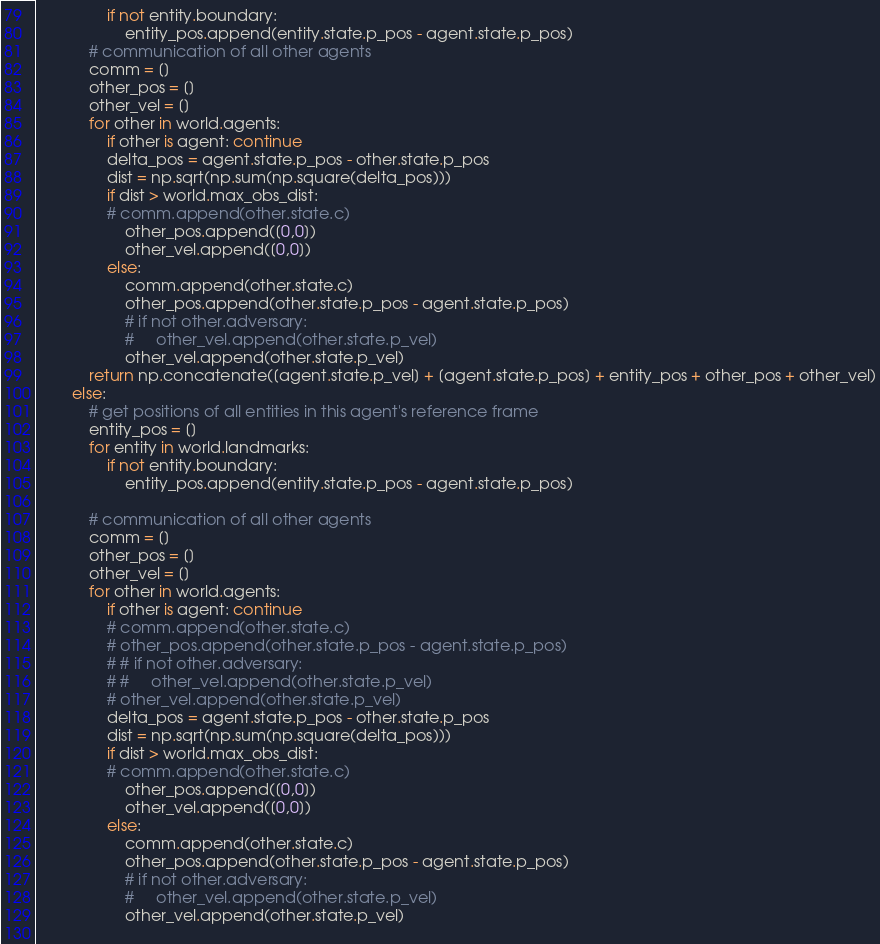Convert code to text. <code><loc_0><loc_0><loc_500><loc_500><_Python_>                if not entity.boundary:
                    entity_pos.append(entity.state.p_pos - agent.state.p_pos)
            # communication of all other agents
            comm = []
            other_pos = []
            other_vel = []
            for other in world.agents:
                if other is agent: continue
                delta_pos = agent.state.p_pos - other.state.p_pos
                dist = np.sqrt(np.sum(np.square(delta_pos)))
                if dist > world.max_obs_dist:
                # comm.append(other.state.c)
                    other_pos.append([0,0])
                    other_vel.append([0,0])
                else:
                    comm.append(other.state.c)
                    other_pos.append(other.state.p_pos - agent.state.p_pos)
                    # if not other.adversary:
                    #     other_vel.append(other.state.p_vel)
                    other_vel.append(other.state.p_vel)
            return np.concatenate([agent.state.p_vel] + [agent.state.p_pos] + entity_pos + other_pos + other_vel)
        else:
            # get positions of all entities in this agent's reference frame
            entity_pos = []
            for entity in world.landmarks:
                if not entity.boundary:
                    entity_pos.append(entity.state.p_pos - agent.state.p_pos)

            # communication of all other agents
            comm = []
            other_pos = []
            other_vel = []
            for other in world.agents:
                if other is agent: continue
                # comm.append(other.state.c)
                # other_pos.append(other.state.p_pos - agent.state.p_pos)
                # # if not other.adversary:
                # #     other_vel.append(other.state.p_vel)
                # other_vel.append(other.state.p_vel)
                delta_pos = agent.state.p_pos - other.state.p_pos
                dist = np.sqrt(np.sum(np.square(delta_pos)))
                if dist > world.max_obs_dist:
                # comm.append(other.state.c)
                    other_pos.append([0,0])
                    other_vel.append([0,0])
                else:
                    comm.append(other.state.c)
                    other_pos.append(other.state.p_pos - agent.state.p_pos)
                    # if not other.adversary:
                    #     other_vel.append(other.state.p_vel)
                    other_vel.append(other.state.p_vel)
                </code> 